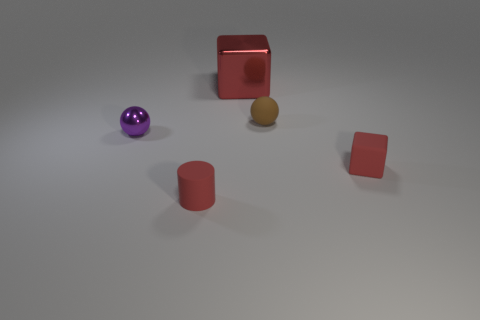What number of yellow cylinders have the same material as the large block?
Your response must be concise. 0. Are there fewer small cylinders that are behind the matte block than tiny cylinders?
Keep it short and to the point. Yes. There is a thing that is on the left side of the small matte thing to the left of the large metallic block; what is its size?
Ensure brevity in your answer.  Small. Does the large object have the same color as the tiny ball behind the purple metallic sphere?
Offer a terse response. No. What is the material of the purple object that is the same size as the matte cylinder?
Make the answer very short. Metal. Are there fewer red matte cubes that are to the left of the tiny red cylinder than tiny purple shiny objects to the right of the rubber block?
Offer a terse response. No. The tiny red matte thing that is in front of the red block that is in front of the purple sphere is what shape?
Offer a very short reply. Cylinder. Are any brown objects visible?
Give a very brief answer. Yes. What color is the cube behind the matte block?
Your answer should be very brief. Red. What is the material of the cylinder that is the same color as the tiny cube?
Give a very brief answer. Rubber. 